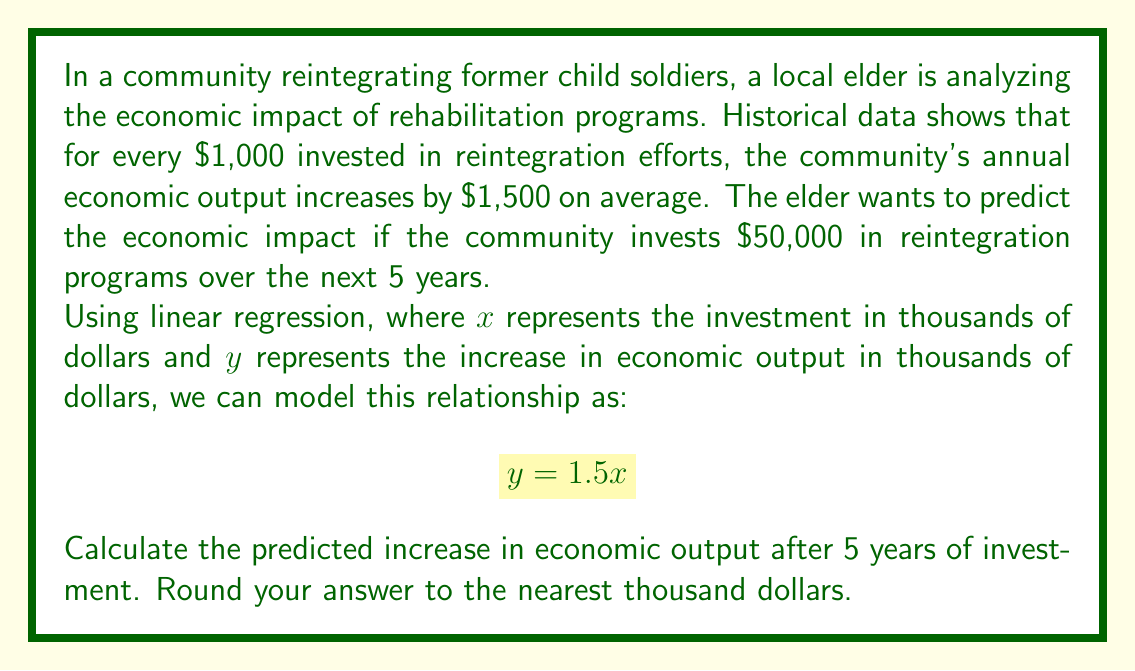Teach me how to tackle this problem. Let's approach this step-by-step:

1) First, we need to understand the given information:
   - For every $1,000 invested, the economic output increases by $1,500
   - The community plans to invest $50,000 over 5 years
   - The linear regression model is $y = 1.5x$

2) We need to convert the investment amount to the units used in our model:
   $50,000 ÷ 1,000 = 50$ (because $x$ is in thousands of dollars)

3) Now we can plug this value into our linear regression equation:
   $y = 1.5x$
   $y = 1.5 * 50$
   $y = 75$

4) Remember that $y$ is also in thousands of dollars, so we need to convert it back:
   $75 * 1,000 = 75,000$

5) Therefore, the predicted increase in economic output after 5 years of $50,000 investment is $75,000.

This linear model assumes a constant rate of return on investment over time. In reality, economic impacts may be more complex and non-linear, but this simple model provides a reasonable estimate for planning purposes.
Answer: $75,000 